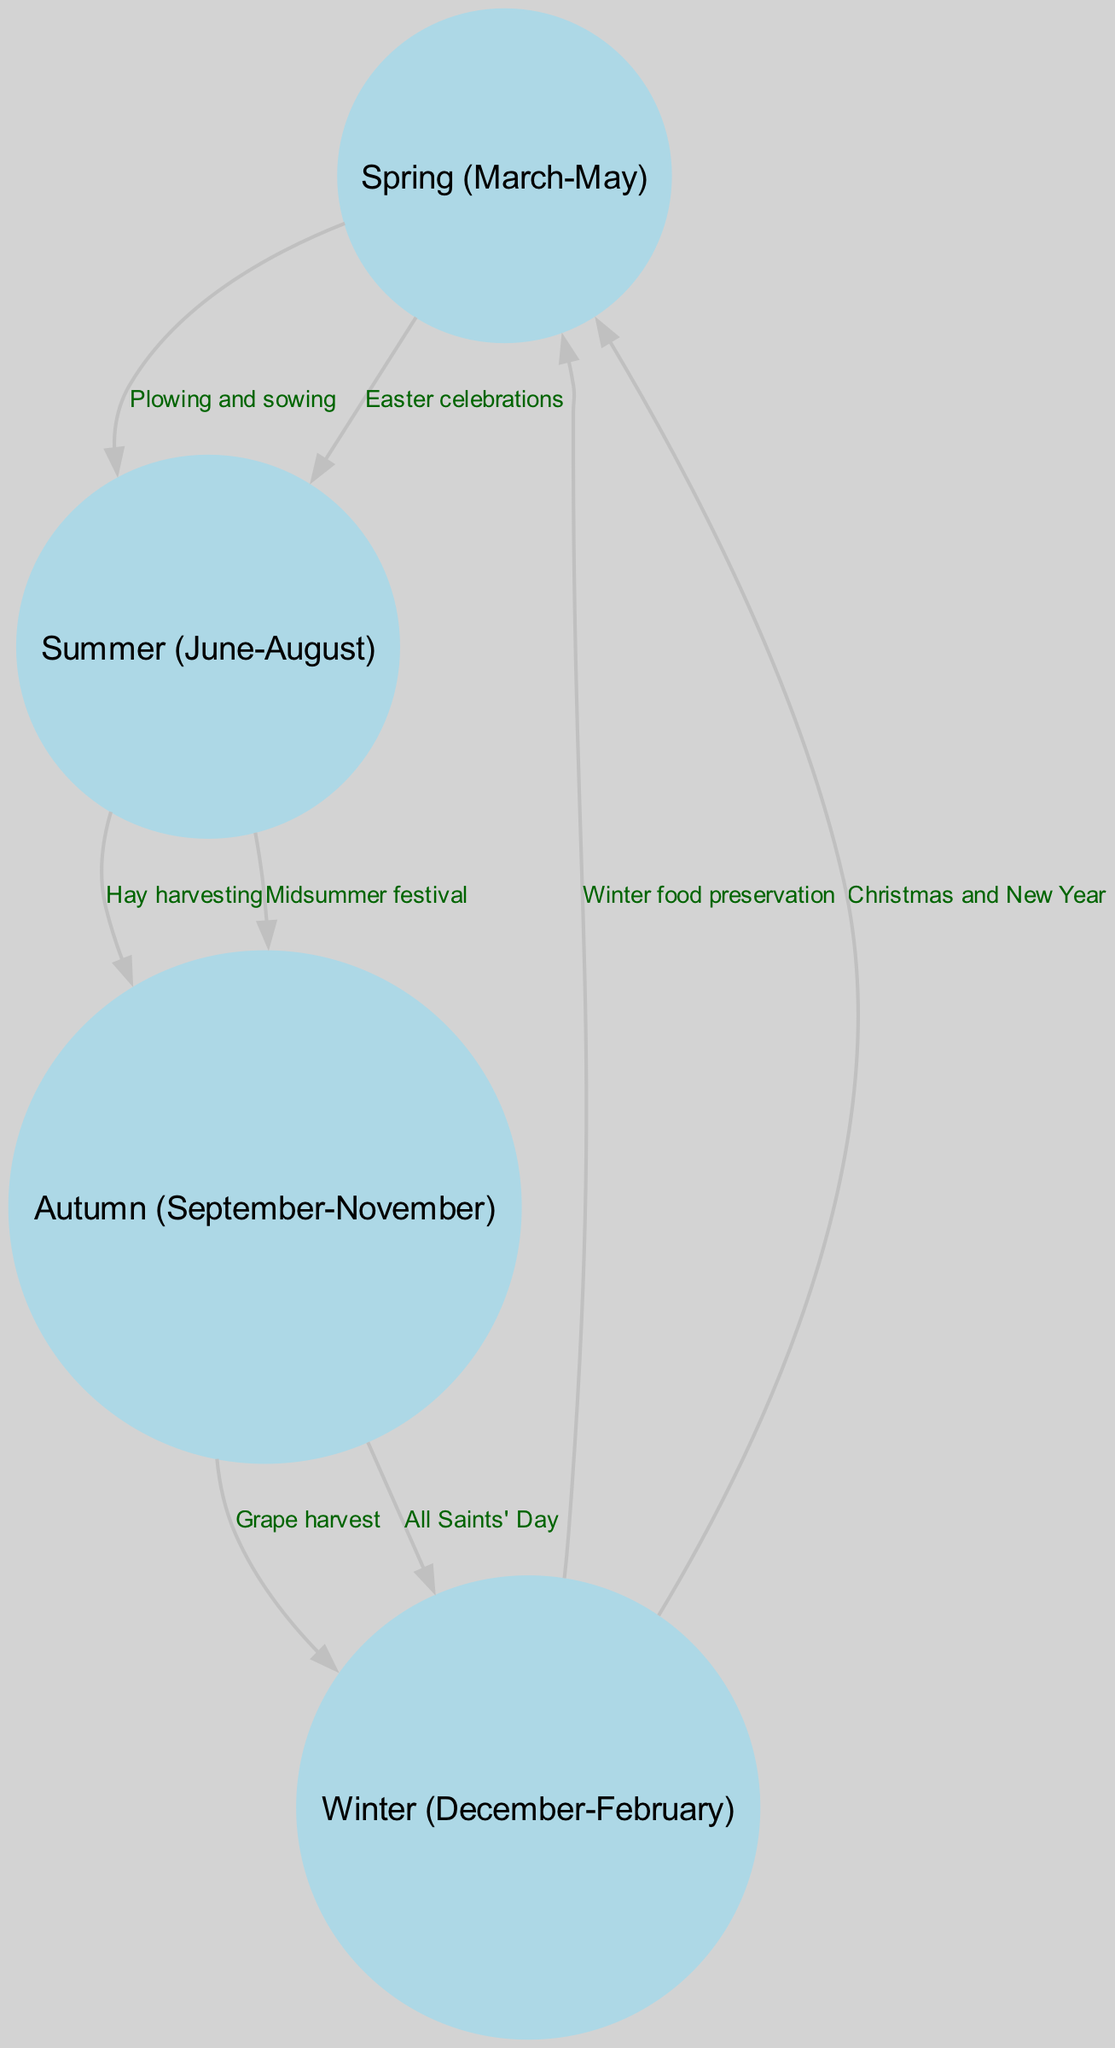What is the first season depicted in the diagram? The diagram begins with Spring (March-May) as the first season listed among the nodes.
Answer: Spring (March-May) How many nodes are there in the diagram? Counting the individual sections represented as nodes, there are four identified nodes: Spring, Summer, Autumn, and Winter.
Answer: 4 What is the activity linked with Easter celebrations? The diagram shows that Easter celebrations flow from the Spring node, indicating they occur during this first season.
Answer: Easter celebrations Which festival is connected to the transition from Summer to Autumn? The Midsummer festival is identified as an event occurring in the Summer, and it transitions directly to Autumn activities.
Answer: Midsummer festival What seasonal activity involves grape harvest? In the Autumn section, there is an edge indicating the activity of grape harvest. This connects Autumn to Winter in the cycle of activities.
Answer: Grape harvest What is the last seasonal event mentioned in the diagram? The last event listed in the diagram is Christmas and New Year, which is connected to Winter (December-February) and flows back into Spring.
Answer: Christmas and New Year From Spring to Summer, how many activities are listed? According to the edges, there are two activities that flow from Spring to Summer: Plowing and sowing, and Easter celebrations.
Answer: 2 Which season follows Autumn in the diagram? The diagram shows Winter (December-February) following Autumn (September-November) in the annual cycle of activities.
Answer: Winter (December-February) What is the connection between Winter and Spring? The diagram shows that Winter food preservation and Christmas and New Year activities flow back to Spring, indicating a cyclical relationship.
Answer: Winter food preservation and Christmas and New Year 